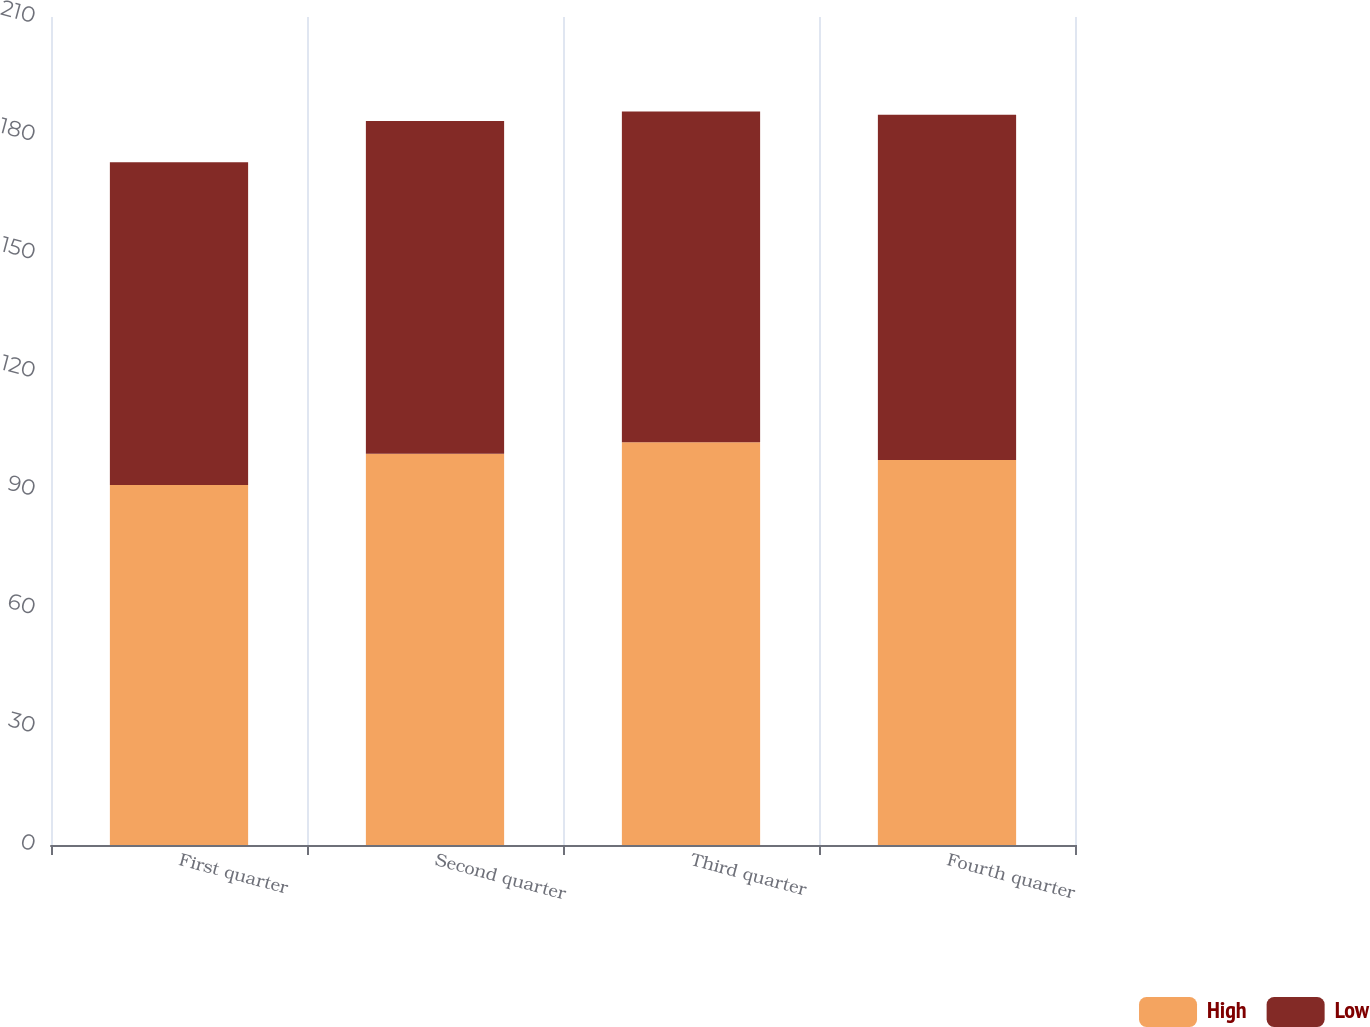Convert chart. <chart><loc_0><loc_0><loc_500><loc_500><stacked_bar_chart><ecel><fcel>First quarter<fcel>Second quarter<fcel>Third quarter<fcel>Fourth quarter<nl><fcel>High<fcel>91.29<fcel>99.26<fcel>102.17<fcel>97.62<nl><fcel>Low<fcel>81.9<fcel>84.37<fcel>83.89<fcel>87.56<nl></chart> 